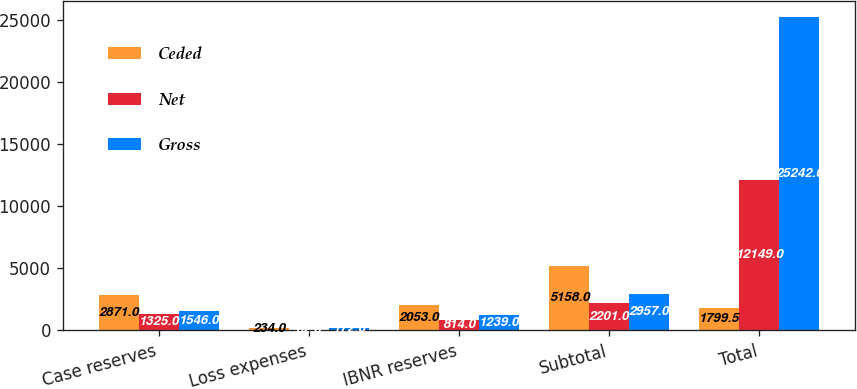Convert chart to OTSL. <chart><loc_0><loc_0><loc_500><loc_500><stacked_bar_chart><ecel><fcel>Case reserves<fcel>Loss expenses<fcel>IBNR reserves<fcel>Subtotal<fcel>Total<nl><fcel>Ceded<fcel>2871<fcel>234<fcel>2053<fcel>5158<fcel>1799.5<nl><fcel>Net<fcel>1325<fcel>62<fcel>814<fcel>2201<fcel>12149<nl><fcel>Gross<fcel>1546<fcel>172<fcel>1239<fcel>2957<fcel>25242<nl></chart> 